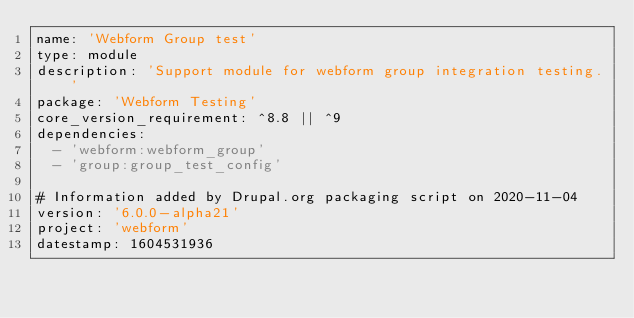Convert code to text. <code><loc_0><loc_0><loc_500><loc_500><_YAML_>name: 'Webform Group test'
type: module
description: 'Support module for webform group integration testing.'
package: 'Webform Testing'
core_version_requirement: ^8.8 || ^9
dependencies:
  - 'webform:webform_group'
  - 'group:group_test_config'

# Information added by Drupal.org packaging script on 2020-11-04
version: '6.0.0-alpha21'
project: 'webform'
datestamp: 1604531936
</code> 